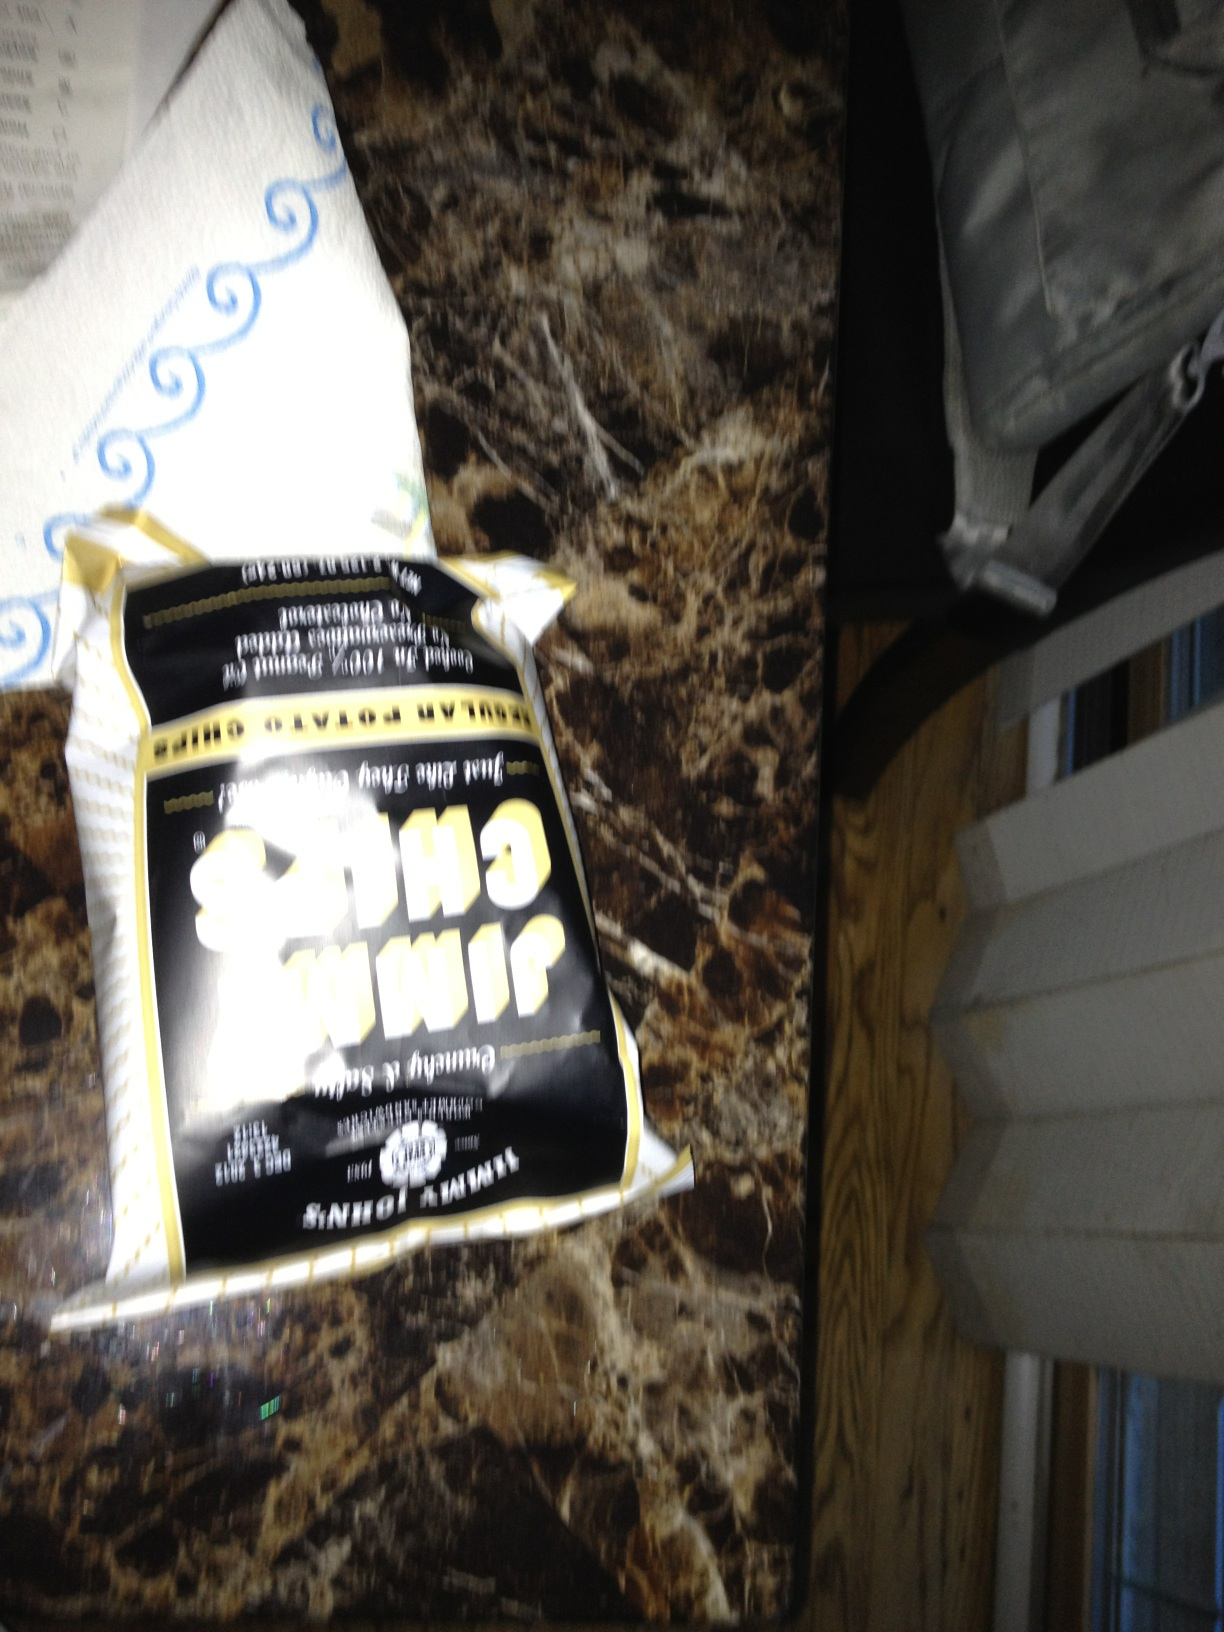Can you guess what time of day this photo was taken? Based solely on the image, it's quite challenging to accurately determine the time of day. However, the use of indoor lighting without any visible natural light coming through might suggest that it was taken either at night or in a room without windows during the day. 